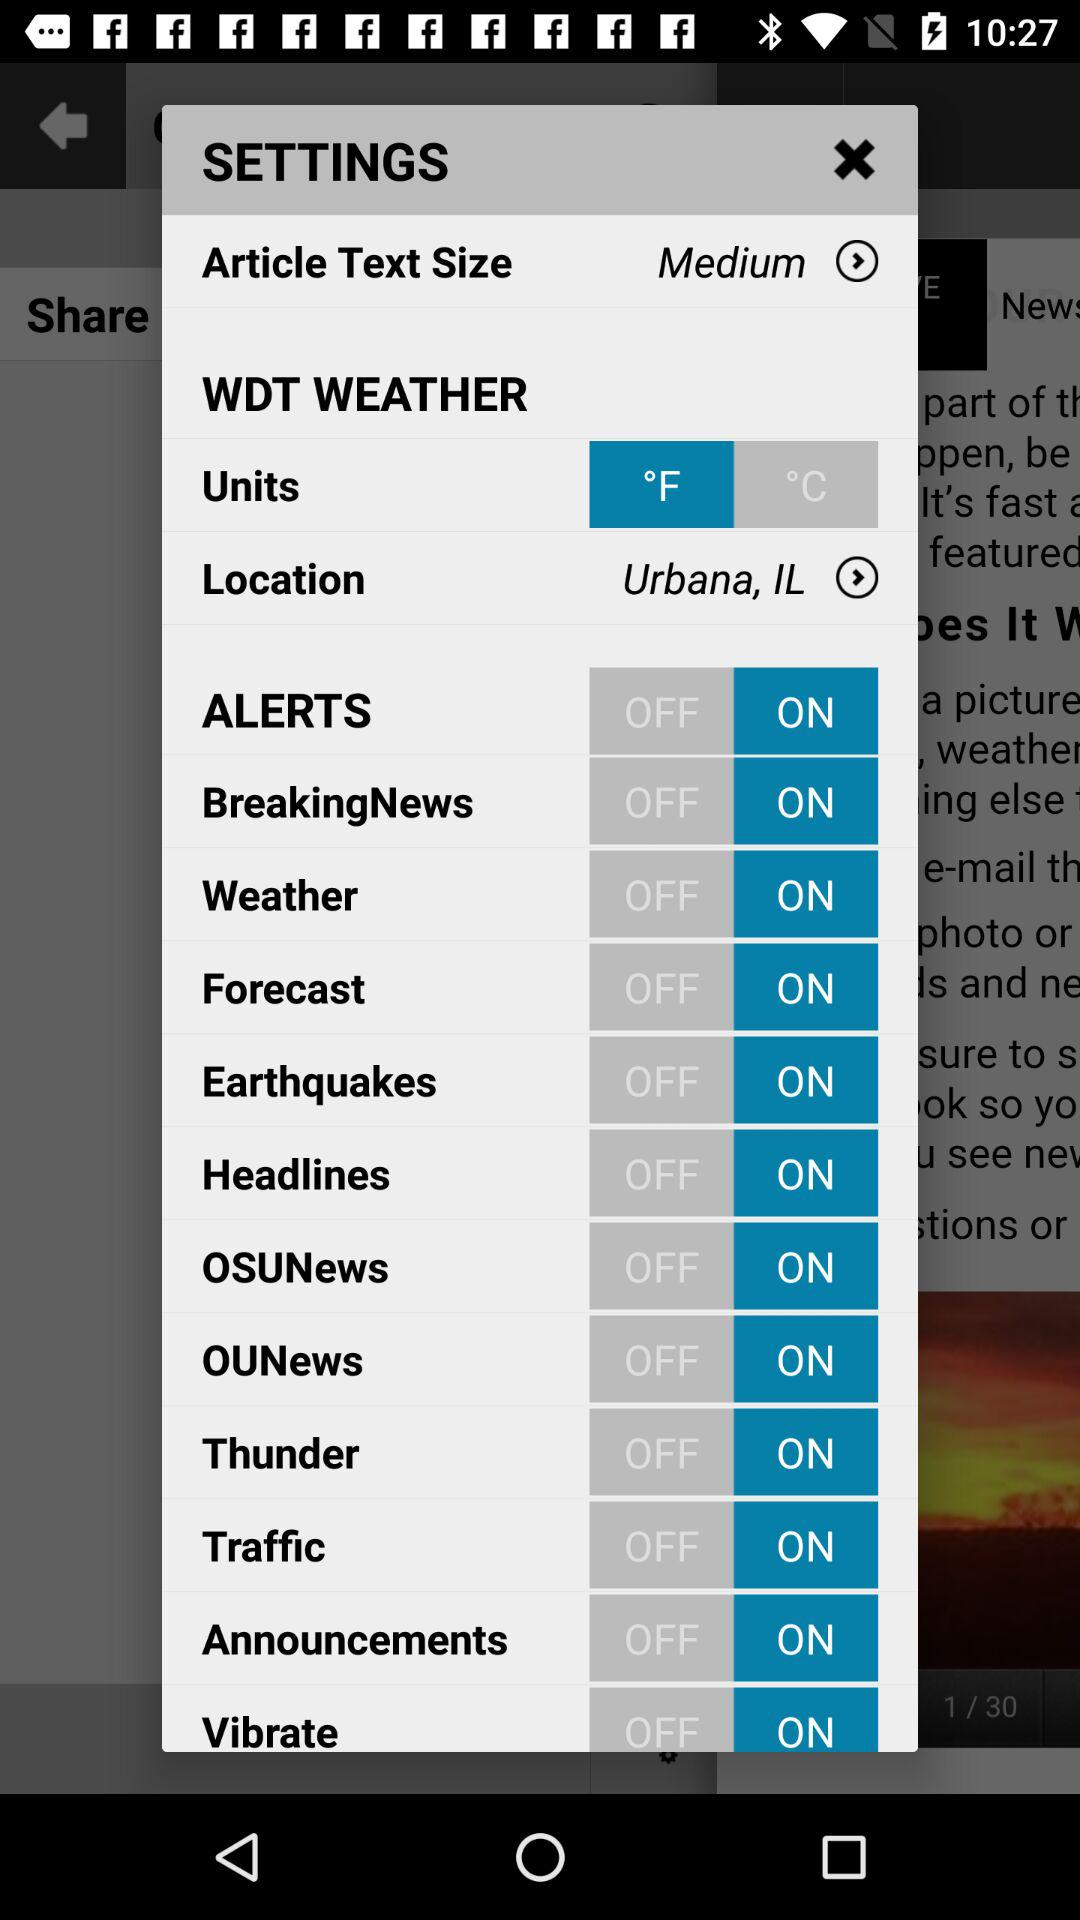What is the article text size? The article text size is medium. 